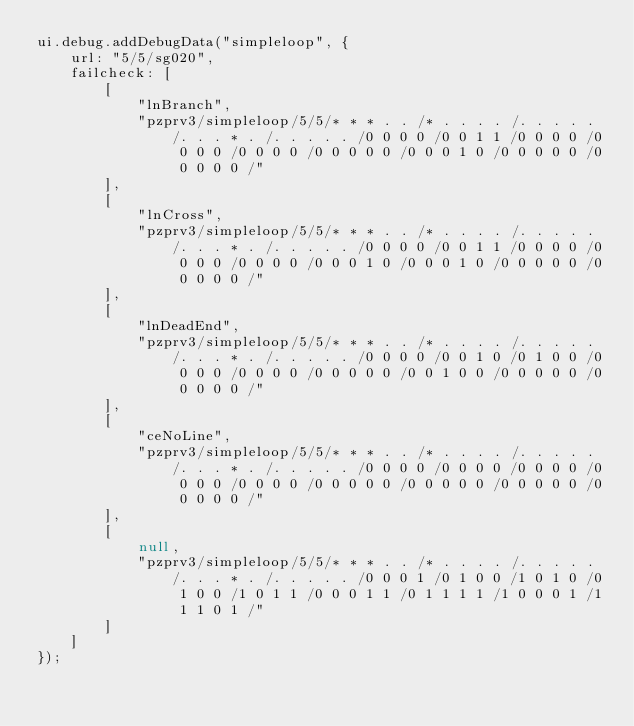Convert code to text. <code><loc_0><loc_0><loc_500><loc_500><_JavaScript_>ui.debug.addDebugData("simpleloop", {
	url: "5/5/sg020",
	failcheck: [
		[
			"lnBranch",
			"pzprv3/simpleloop/5/5/* * * . . /* . . . . /. . . . . /. . . * . /. . . . . /0 0 0 0 /0 0 1 1 /0 0 0 0 /0 0 0 0 /0 0 0 0 /0 0 0 0 0 /0 0 0 1 0 /0 0 0 0 0 /0 0 0 0 0 /"
		],
		[
			"lnCross",
			"pzprv3/simpleloop/5/5/* * * . . /* . . . . /. . . . . /. . . * . /. . . . . /0 0 0 0 /0 0 1 1 /0 0 0 0 /0 0 0 0 /0 0 0 0 /0 0 0 1 0 /0 0 0 1 0 /0 0 0 0 0 /0 0 0 0 0 /"
		],
		[
			"lnDeadEnd",
			"pzprv3/simpleloop/5/5/* * * . . /* . . . . /. . . . . /. . . * . /. . . . . /0 0 0 0 /0 0 1 0 /0 1 0 0 /0 0 0 0 /0 0 0 0 /0 0 0 0 0 /0 0 1 0 0 /0 0 0 0 0 /0 0 0 0 0 /"
		],
		[
			"ceNoLine",
			"pzprv3/simpleloop/5/5/* * * . . /* . . . . /. . . . . /. . . * . /. . . . . /0 0 0 0 /0 0 0 0 /0 0 0 0 /0 0 0 0 /0 0 0 0 /0 0 0 0 0 /0 0 0 0 0 /0 0 0 0 0 /0 0 0 0 0 /"
		],
		[
			null,
			"pzprv3/simpleloop/5/5/* * * . . /* . . . . /. . . . . /. . . * . /. . . . . /0 0 0 1 /0 1 0 0 /1 0 1 0 /0 1 0 0 /1 0 1 1 /0 0 0 1 1 /0 1 1 1 1 /1 0 0 0 1 /1 1 1 0 1 /"
		]
	]
});
</code> 